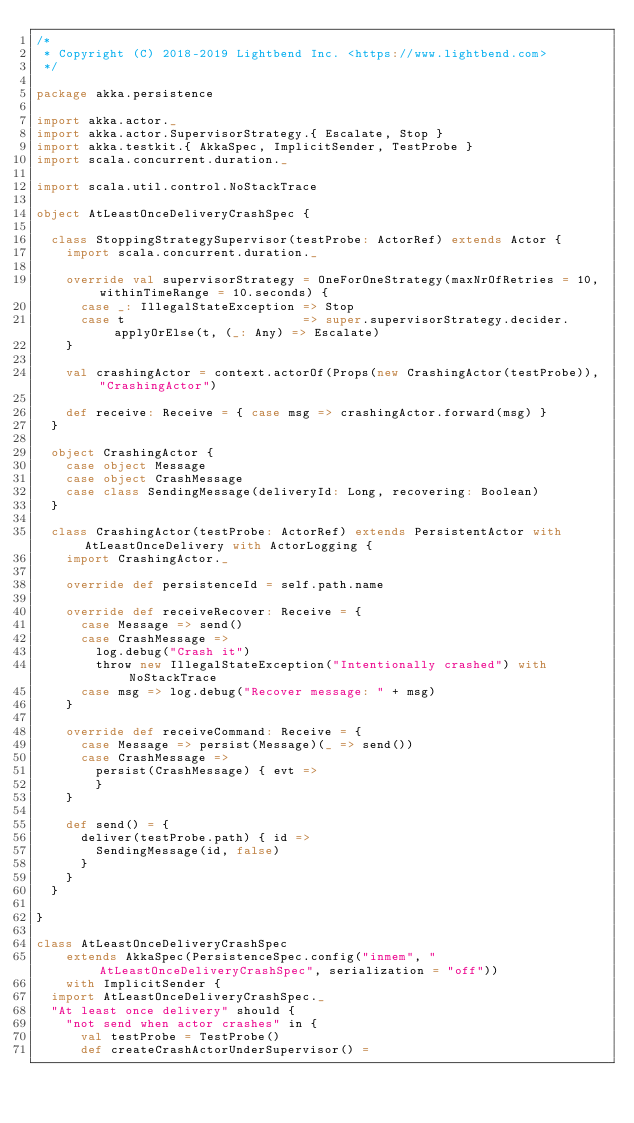<code> <loc_0><loc_0><loc_500><loc_500><_Scala_>/*
 * Copyright (C) 2018-2019 Lightbend Inc. <https://www.lightbend.com>
 */

package akka.persistence

import akka.actor._
import akka.actor.SupervisorStrategy.{ Escalate, Stop }
import akka.testkit.{ AkkaSpec, ImplicitSender, TestProbe }
import scala.concurrent.duration._

import scala.util.control.NoStackTrace

object AtLeastOnceDeliveryCrashSpec {

  class StoppingStrategySupervisor(testProbe: ActorRef) extends Actor {
    import scala.concurrent.duration._

    override val supervisorStrategy = OneForOneStrategy(maxNrOfRetries = 10, withinTimeRange = 10.seconds) {
      case _: IllegalStateException => Stop
      case t                        => super.supervisorStrategy.decider.applyOrElse(t, (_: Any) => Escalate)
    }

    val crashingActor = context.actorOf(Props(new CrashingActor(testProbe)), "CrashingActor")

    def receive: Receive = { case msg => crashingActor.forward(msg) }
  }

  object CrashingActor {
    case object Message
    case object CrashMessage
    case class SendingMessage(deliveryId: Long, recovering: Boolean)
  }

  class CrashingActor(testProbe: ActorRef) extends PersistentActor with AtLeastOnceDelivery with ActorLogging {
    import CrashingActor._

    override def persistenceId = self.path.name

    override def receiveRecover: Receive = {
      case Message => send()
      case CrashMessage =>
        log.debug("Crash it")
        throw new IllegalStateException("Intentionally crashed") with NoStackTrace
      case msg => log.debug("Recover message: " + msg)
    }

    override def receiveCommand: Receive = {
      case Message => persist(Message)(_ => send())
      case CrashMessage =>
        persist(CrashMessage) { evt =>
        }
    }

    def send() = {
      deliver(testProbe.path) { id =>
        SendingMessage(id, false)
      }
    }
  }

}

class AtLeastOnceDeliveryCrashSpec
    extends AkkaSpec(PersistenceSpec.config("inmem", "AtLeastOnceDeliveryCrashSpec", serialization = "off"))
    with ImplicitSender {
  import AtLeastOnceDeliveryCrashSpec._
  "At least once delivery" should {
    "not send when actor crashes" in {
      val testProbe = TestProbe()
      def createCrashActorUnderSupervisor() =</code> 